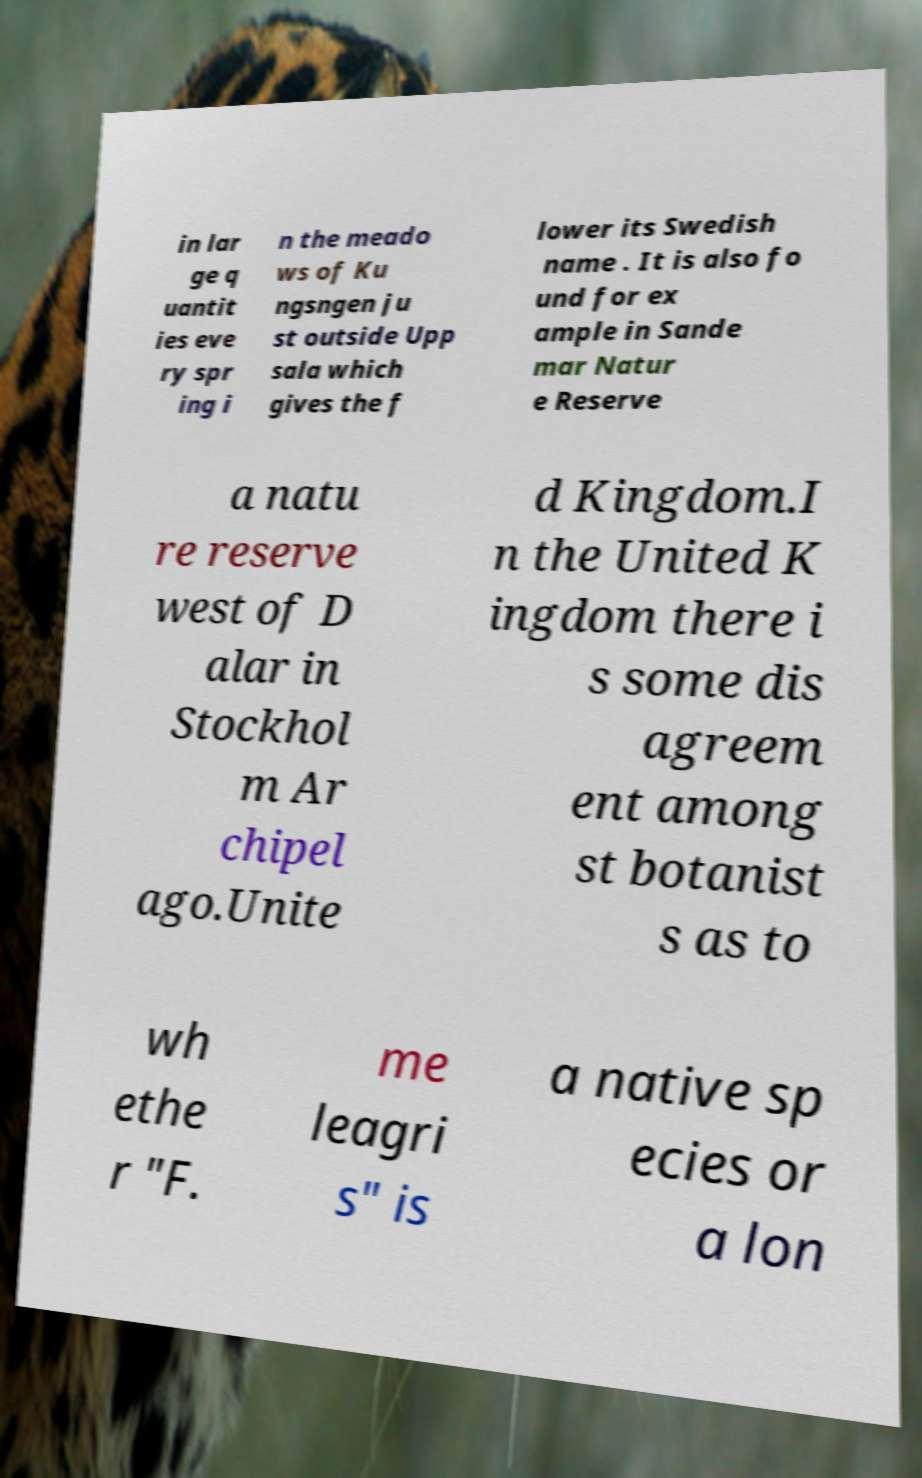Please identify and transcribe the text found in this image. in lar ge q uantit ies eve ry spr ing i n the meado ws of Ku ngsngen ju st outside Upp sala which gives the f lower its Swedish name . It is also fo und for ex ample in Sande mar Natur e Reserve a natu re reserve west of D alar in Stockhol m Ar chipel ago.Unite d Kingdom.I n the United K ingdom there i s some dis agreem ent among st botanist s as to wh ethe r "F. me leagri s" is a native sp ecies or a lon 